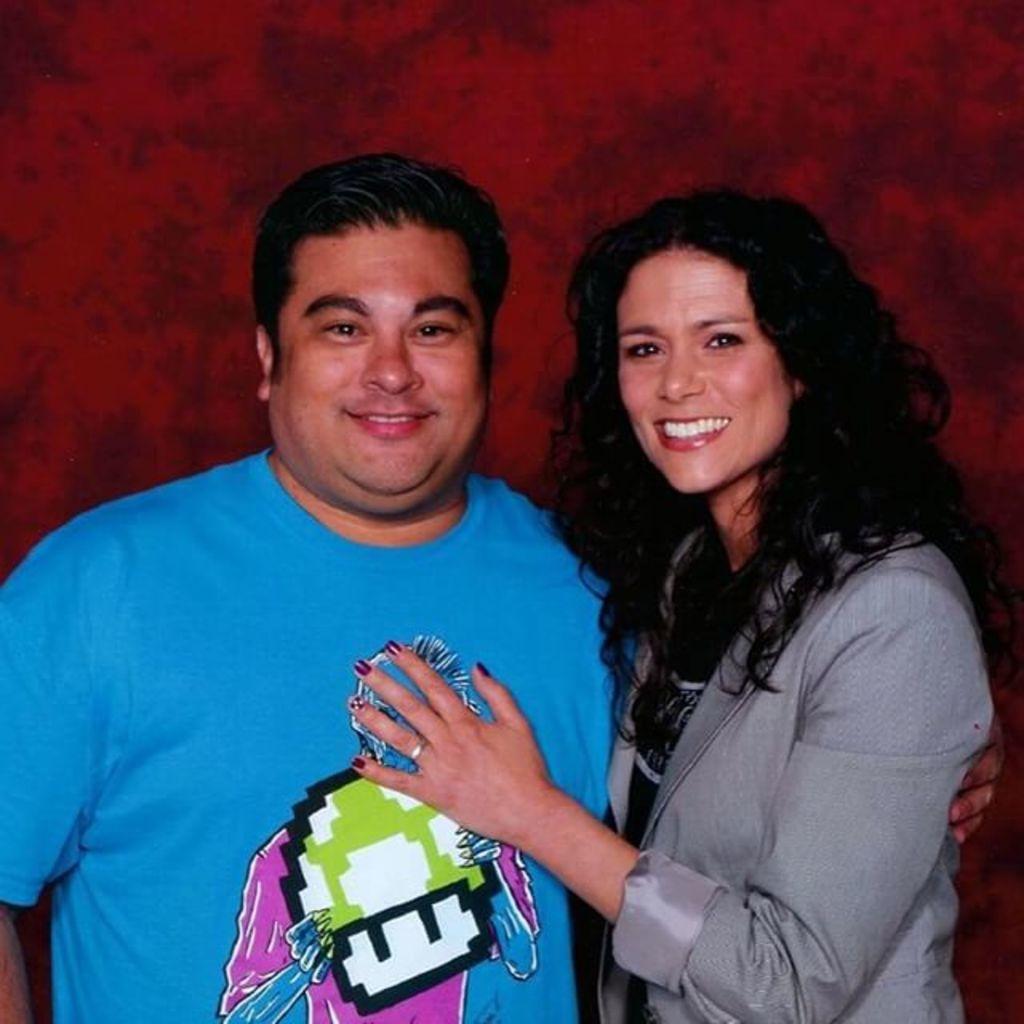Please provide a concise description of this image. In this image we can see a man and a woman holding each other. 